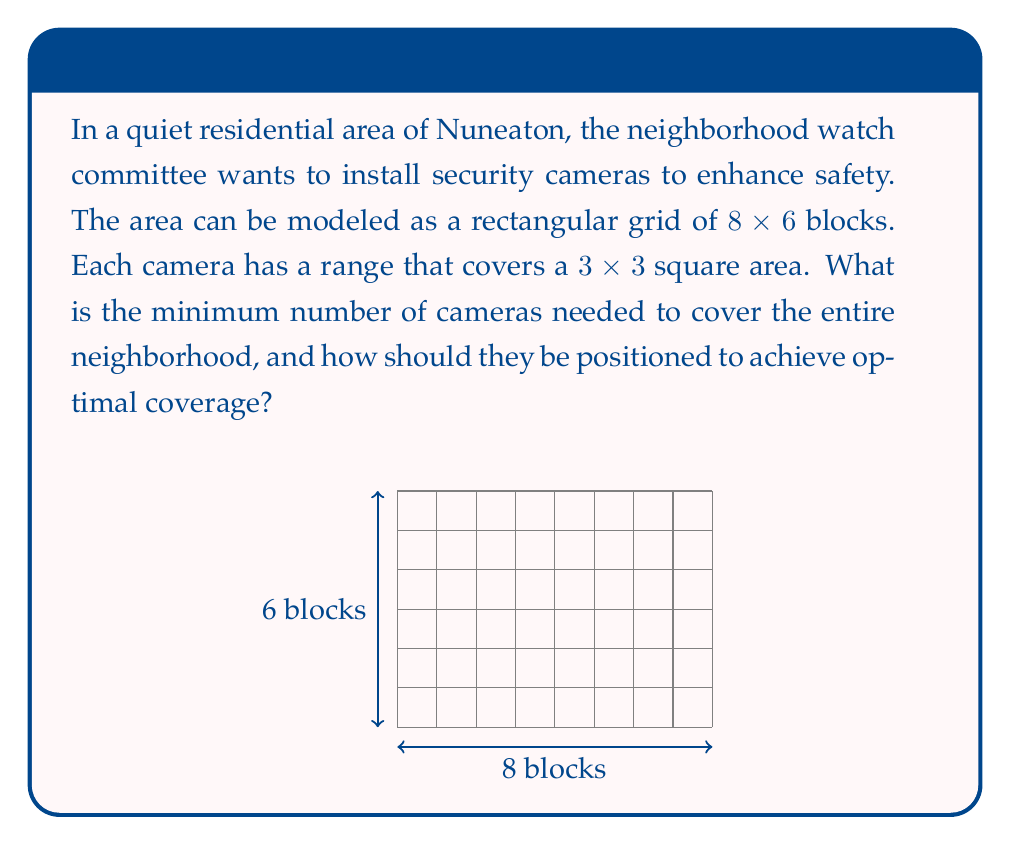Teach me how to tackle this problem. To solve this problem, we'll follow these steps:

1) First, let's consider the coverage of each camera. Each camera covers a $3 \times 3$ area, which means it can cover 9 blocks.

2) The total area to be covered is $8 \times 6 = 48$ blocks.

3) If we were to simply divide the total area by the coverage of each camera, we'd get $48 \div 9 \approx 5.33$. However, this doesn't account for overlap or edge effects.

4) To minimize the number of cameras, we need to position them strategically to maximize coverage and minimize overlap. The optimal placement is to put cameras at the following coordinates (assuming the bottom-left corner is (0,0)):

   $$(1,1), (4,1), (7,1), (1,4), (4,4), (7,4)$$

5) This placement ensures that:
   - Each camera is positioned to cover a $3 \times 3$ area
   - The cameras on the edges cover the border areas
   - There is minimal overlap between camera coverages

6) With this arrangement, we can cover the entire $8 \times 6$ grid with just 6 cameras.

[asy]
size(200,150);
for(int i=0; i<=8; ++i) draw((i,0)--(i,6),gray);
for(int j=0; j<=6; ++j) draw((0,j)--(8,j),gray);
dot((1,1)); dot((4,1)); dot((7,1));
dot((1,4)); dot((4,4)); dot((7,4));
label("C", (1,1), SW);
label("C", (4,1), S);
label("C", (7,1), SE);
label("C", (1,4), NW);
label("C", (4,4), N);
label("C", (7,4), NE);
[/asy]

This solution ensures complete coverage of the neighborhood while using the minimum number of cameras, which is both cost-effective and efficient for the neighborhood watch committee.
Answer: The minimum number of cameras needed is 6, positioned at coordinates (1,1), (4,1), (7,1), (1,4), (4,4), and (7,4) on the $8 \times 6$ grid. 